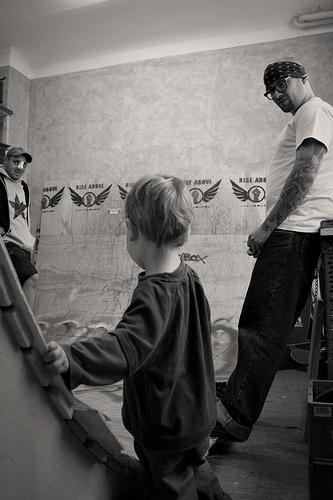What do you call the writing on the wall?
Be succinct. Graffiti. Does this picture looked staged?
Be succinct. No. Is it busy here?
Short answer required. No. How many items of clothing can you see the child wearing?
Write a very short answer. 2. How many people are there?
Write a very short answer. 3. Is anybody wearing glasses?
Answer briefly. Yes. What is the child pushing?
Be succinct. Nothing. Why is a man in the picture wearing sunglasses?
Give a very brief answer. Bright. What two types of head wear are shown?
Write a very short answer. Hat and bandana. 